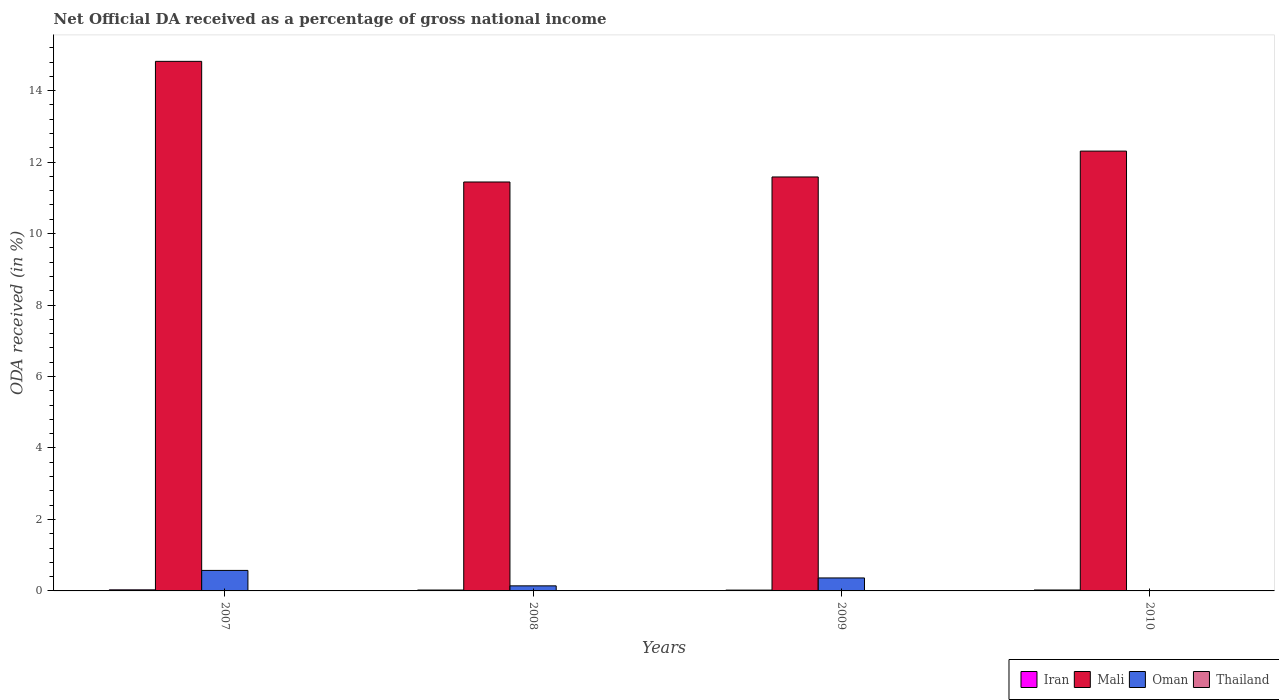How many groups of bars are there?
Ensure brevity in your answer.  4. How many bars are there on the 3rd tick from the left?
Make the answer very short. 3. What is the label of the 2nd group of bars from the left?
Keep it short and to the point. 2008. In how many cases, is the number of bars for a given year not equal to the number of legend labels?
Offer a very short reply. 4. What is the net official DA received in Iran in 2010?
Provide a succinct answer. 0.03. Across all years, what is the maximum net official DA received in Mali?
Keep it short and to the point. 14.82. Across all years, what is the minimum net official DA received in Iran?
Provide a succinct answer. 0.02. What is the total net official DA received in Iran in the graph?
Your answer should be very brief. 0.1. What is the difference between the net official DA received in Mali in 2007 and that in 2010?
Your answer should be very brief. 2.51. What is the difference between the net official DA received in Oman in 2007 and the net official DA received in Iran in 2009?
Provide a short and direct response. 0.55. What is the average net official DA received in Oman per year?
Give a very brief answer. 0.27. In the year 2007, what is the difference between the net official DA received in Mali and net official DA received in Iran?
Offer a terse response. 14.79. What is the ratio of the net official DA received in Iran in 2007 to that in 2010?
Make the answer very short. 1.17. What is the difference between the highest and the second highest net official DA received in Mali?
Give a very brief answer. 2.51. What is the difference between the highest and the lowest net official DA received in Iran?
Provide a short and direct response. 0.01. In how many years, is the net official DA received in Oman greater than the average net official DA received in Oman taken over all years?
Offer a terse response. 2. Is it the case that in every year, the sum of the net official DA received in Oman and net official DA received in Iran is greater than the sum of net official DA received in Mali and net official DA received in Thailand?
Make the answer very short. No. Are all the bars in the graph horizontal?
Offer a terse response. No. Are the values on the major ticks of Y-axis written in scientific E-notation?
Provide a succinct answer. No. Does the graph contain any zero values?
Offer a terse response. Yes. Does the graph contain grids?
Give a very brief answer. No. What is the title of the graph?
Offer a very short reply. Net Official DA received as a percentage of gross national income. Does "Namibia" appear as one of the legend labels in the graph?
Ensure brevity in your answer.  No. What is the label or title of the Y-axis?
Provide a short and direct response. ODA received (in %). What is the ODA received (in %) in Iran in 2007?
Your answer should be compact. 0.03. What is the ODA received (in %) in Mali in 2007?
Ensure brevity in your answer.  14.82. What is the ODA received (in %) in Oman in 2007?
Offer a very short reply. 0.57. What is the ODA received (in %) of Iran in 2008?
Ensure brevity in your answer.  0.02. What is the ODA received (in %) of Mali in 2008?
Ensure brevity in your answer.  11.44. What is the ODA received (in %) in Oman in 2008?
Provide a short and direct response. 0.14. What is the ODA received (in %) in Iran in 2009?
Provide a succinct answer. 0.02. What is the ODA received (in %) of Mali in 2009?
Offer a terse response. 11.58. What is the ODA received (in %) of Oman in 2009?
Your answer should be very brief. 0.36. What is the ODA received (in %) in Iran in 2010?
Provide a succinct answer. 0.03. What is the ODA received (in %) of Mali in 2010?
Your response must be concise. 12.31. What is the ODA received (in %) in Oman in 2010?
Make the answer very short. 0. What is the ODA received (in %) in Thailand in 2010?
Keep it short and to the point. 0. Across all years, what is the maximum ODA received (in %) in Iran?
Offer a very short reply. 0.03. Across all years, what is the maximum ODA received (in %) of Mali?
Provide a succinct answer. 14.82. Across all years, what is the maximum ODA received (in %) of Oman?
Give a very brief answer. 0.57. Across all years, what is the minimum ODA received (in %) of Iran?
Your response must be concise. 0.02. Across all years, what is the minimum ODA received (in %) of Mali?
Keep it short and to the point. 11.44. What is the total ODA received (in %) in Iran in the graph?
Give a very brief answer. 0.1. What is the total ODA received (in %) of Mali in the graph?
Provide a short and direct response. 50.15. What is the total ODA received (in %) in Oman in the graph?
Provide a short and direct response. 1.08. What is the total ODA received (in %) of Thailand in the graph?
Make the answer very short. 0. What is the difference between the ODA received (in %) in Iran in 2007 and that in 2008?
Ensure brevity in your answer.  0.01. What is the difference between the ODA received (in %) of Mali in 2007 and that in 2008?
Provide a succinct answer. 3.38. What is the difference between the ODA received (in %) of Oman in 2007 and that in 2008?
Your answer should be very brief. 0.43. What is the difference between the ODA received (in %) in Iran in 2007 and that in 2009?
Provide a succinct answer. 0.01. What is the difference between the ODA received (in %) in Mali in 2007 and that in 2009?
Provide a short and direct response. 3.24. What is the difference between the ODA received (in %) in Oman in 2007 and that in 2009?
Your response must be concise. 0.21. What is the difference between the ODA received (in %) of Iran in 2007 and that in 2010?
Provide a succinct answer. 0. What is the difference between the ODA received (in %) in Mali in 2007 and that in 2010?
Provide a short and direct response. 2.51. What is the difference between the ODA received (in %) in Iran in 2008 and that in 2009?
Offer a terse response. 0. What is the difference between the ODA received (in %) of Mali in 2008 and that in 2009?
Your response must be concise. -0.14. What is the difference between the ODA received (in %) in Oman in 2008 and that in 2009?
Provide a succinct answer. -0.22. What is the difference between the ODA received (in %) of Iran in 2008 and that in 2010?
Your answer should be very brief. -0. What is the difference between the ODA received (in %) of Mali in 2008 and that in 2010?
Provide a succinct answer. -0.86. What is the difference between the ODA received (in %) of Iran in 2009 and that in 2010?
Your answer should be very brief. -0. What is the difference between the ODA received (in %) in Mali in 2009 and that in 2010?
Your response must be concise. -0.72. What is the difference between the ODA received (in %) in Iran in 2007 and the ODA received (in %) in Mali in 2008?
Your answer should be compact. -11.41. What is the difference between the ODA received (in %) of Iran in 2007 and the ODA received (in %) of Oman in 2008?
Offer a very short reply. -0.11. What is the difference between the ODA received (in %) of Mali in 2007 and the ODA received (in %) of Oman in 2008?
Provide a succinct answer. 14.68. What is the difference between the ODA received (in %) of Iran in 2007 and the ODA received (in %) of Mali in 2009?
Offer a terse response. -11.55. What is the difference between the ODA received (in %) of Iran in 2007 and the ODA received (in %) of Oman in 2009?
Keep it short and to the point. -0.33. What is the difference between the ODA received (in %) of Mali in 2007 and the ODA received (in %) of Oman in 2009?
Your answer should be very brief. 14.46. What is the difference between the ODA received (in %) in Iran in 2007 and the ODA received (in %) in Mali in 2010?
Ensure brevity in your answer.  -12.28. What is the difference between the ODA received (in %) in Iran in 2008 and the ODA received (in %) in Mali in 2009?
Your answer should be compact. -11.56. What is the difference between the ODA received (in %) in Iran in 2008 and the ODA received (in %) in Oman in 2009?
Offer a terse response. -0.34. What is the difference between the ODA received (in %) of Mali in 2008 and the ODA received (in %) of Oman in 2009?
Ensure brevity in your answer.  11.08. What is the difference between the ODA received (in %) in Iran in 2008 and the ODA received (in %) in Mali in 2010?
Offer a terse response. -12.28. What is the difference between the ODA received (in %) of Iran in 2009 and the ODA received (in %) of Mali in 2010?
Your answer should be compact. -12.28. What is the average ODA received (in %) of Iran per year?
Your answer should be compact. 0.03. What is the average ODA received (in %) in Mali per year?
Offer a very short reply. 12.54. What is the average ODA received (in %) in Oman per year?
Offer a terse response. 0.27. In the year 2007, what is the difference between the ODA received (in %) of Iran and ODA received (in %) of Mali?
Keep it short and to the point. -14.79. In the year 2007, what is the difference between the ODA received (in %) of Iran and ODA received (in %) of Oman?
Make the answer very short. -0.54. In the year 2007, what is the difference between the ODA received (in %) of Mali and ODA received (in %) of Oman?
Keep it short and to the point. 14.25. In the year 2008, what is the difference between the ODA received (in %) of Iran and ODA received (in %) of Mali?
Provide a succinct answer. -11.42. In the year 2008, what is the difference between the ODA received (in %) in Iran and ODA received (in %) in Oman?
Give a very brief answer. -0.12. In the year 2008, what is the difference between the ODA received (in %) in Mali and ODA received (in %) in Oman?
Provide a succinct answer. 11.3. In the year 2009, what is the difference between the ODA received (in %) in Iran and ODA received (in %) in Mali?
Provide a short and direct response. -11.56. In the year 2009, what is the difference between the ODA received (in %) in Iran and ODA received (in %) in Oman?
Provide a short and direct response. -0.34. In the year 2009, what is the difference between the ODA received (in %) of Mali and ODA received (in %) of Oman?
Give a very brief answer. 11.22. In the year 2010, what is the difference between the ODA received (in %) of Iran and ODA received (in %) of Mali?
Make the answer very short. -12.28. What is the ratio of the ODA received (in %) in Iran in 2007 to that in 2008?
Your answer should be compact. 1.23. What is the ratio of the ODA received (in %) of Mali in 2007 to that in 2008?
Keep it short and to the point. 1.29. What is the ratio of the ODA received (in %) of Oman in 2007 to that in 2008?
Offer a terse response. 4.05. What is the ratio of the ODA received (in %) in Iran in 2007 to that in 2009?
Provide a succinct answer. 1.31. What is the ratio of the ODA received (in %) of Mali in 2007 to that in 2009?
Offer a very short reply. 1.28. What is the ratio of the ODA received (in %) in Oman in 2007 to that in 2009?
Give a very brief answer. 1.58. What is the ratio of the ODA received (in %) of Iran in 2007 to that in 2010?
Your answer should be compact. 1.17. What is the ratio of the ODA received (in %) in Mali in 2007 to that in 2010?
Offer a terse response. 1.2. What is the ratio of the ODA received (in %) in Iran in 2008 to that in 2009?
Offer a terse response. 1.07. What is the ratio of the ODA received (in %) of Mali in 2008 to that in 2009?
Provide a succinct answer. 0.99. What is the ratio of the ODA received (in %) in Oman in 2008 to that in 2009?
Your answer should be very brief. 0.39. What is the ratio of the ODA received (in %) in Iran in 2008 to that in 2010?
Provide a short and direct response. 0.95. What is the ratio of the ODA received (in %) in Mali in 2008 to that in 2010?
Provide a succinct answer. 0.93. What is the ratio of the ODA received (in %) of Iran in 2009 to that in 2010?
Your answer should be compact. 0.89. What is the difference between the highest and the second highest ODA received (in %) of Iran?
Your answer should be compact. 0. What is the difference between the highest and the second highest ODA received (in %) in Mali?
Your response must be concise. 2.51. What is the difference between the highest and the second highest ODA received (in %) of Oman?
Your answer should be compact. 0.21. What is the difference between the highest and the lowest ODA received (in %) of Iran?
Your answer should be very brief. 0.01. What is the difference between the highest and the lowest ODA received (in %) in Mali?
Your answer should be compact. 3.38. What is the difference between the highest and the lowest ODA received (in %) of Oman?
Provide a succinct answer. 0.57. 